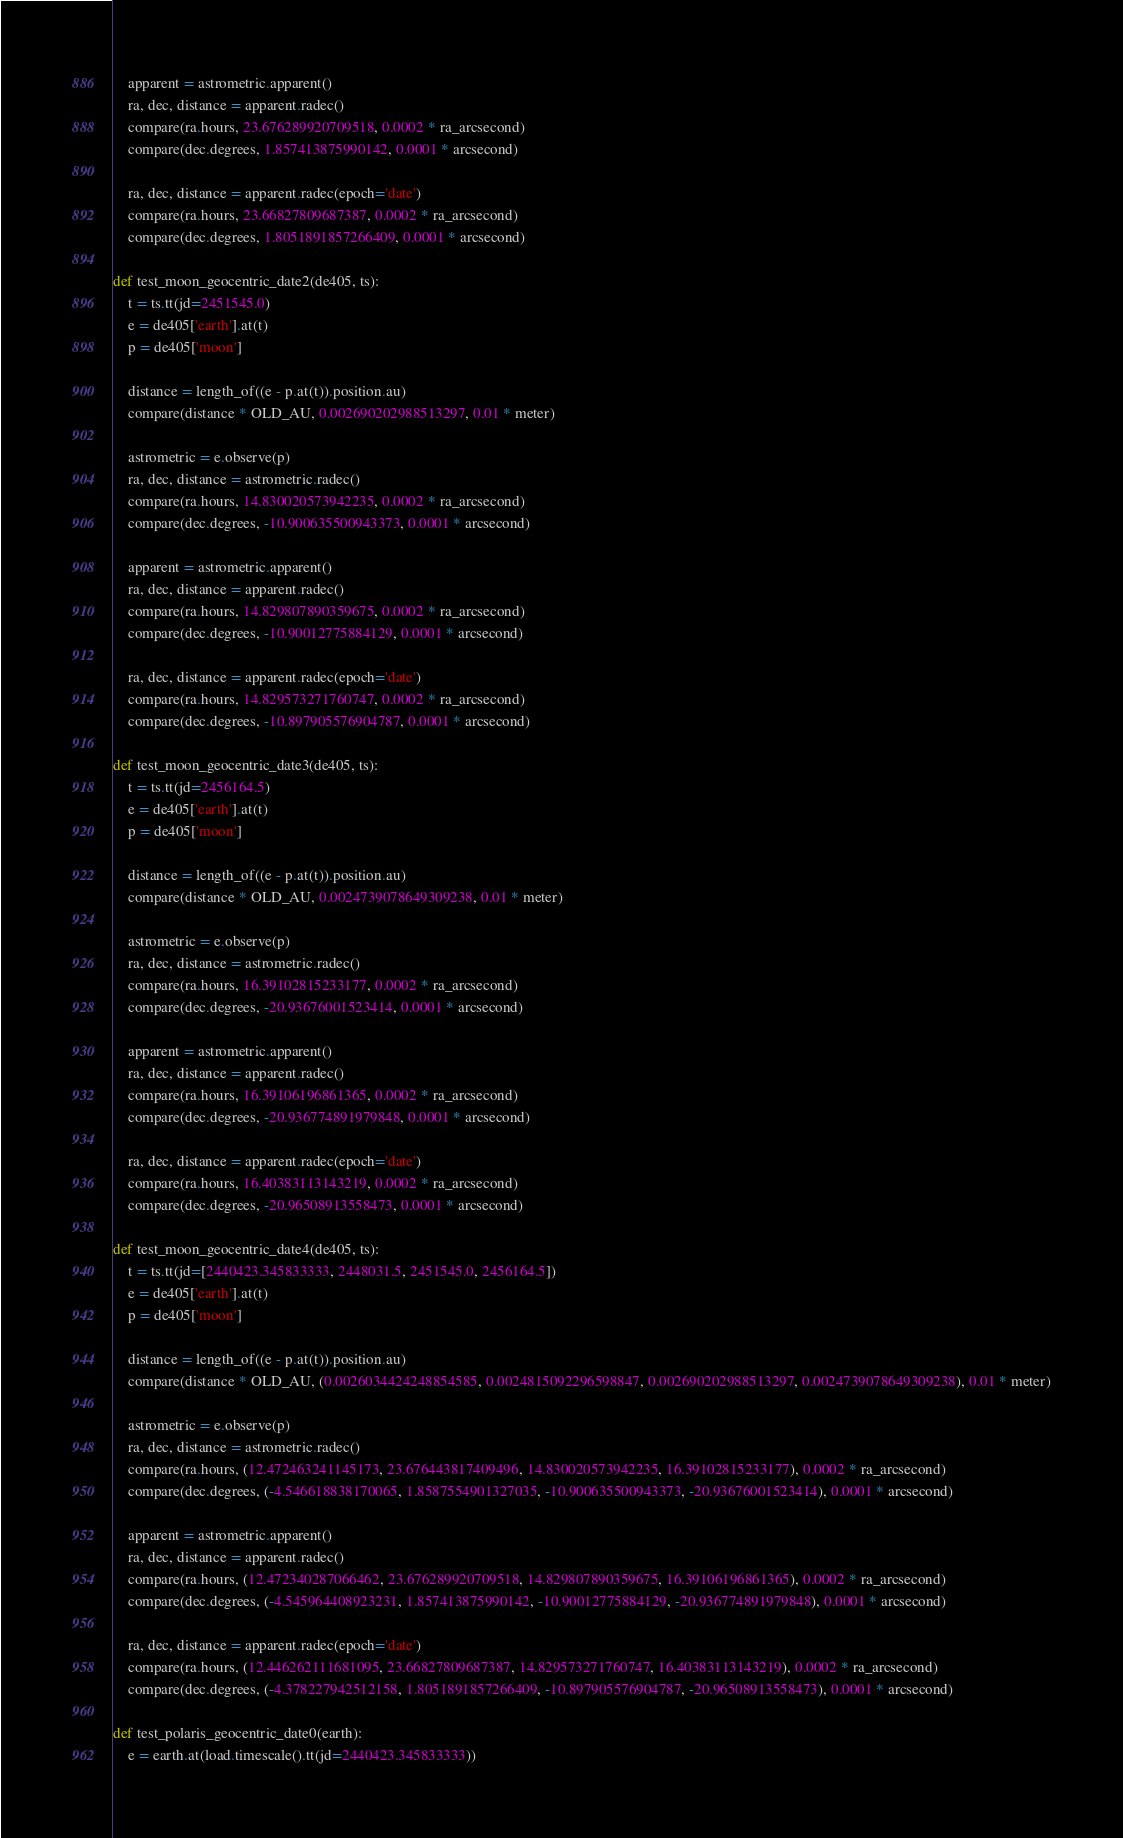<code> <loc_0><loc_0><loc_500><loc_500><_Python_>
    apparent = astrometric.apparent()
    ra, dec, distance = apparent.radec()
    compare(ra.hours, 23.676289920709518, 0.0002 * ra_arcsecond)
    compare(dec.degrees, 1.857413875990142, 0.0001 * arcsecond)

    ra, dec, distance = apparent.radec(epoch='date')
    compare(ra.hours, 23.66827809687387, 0.0002 * ra_arcsecond)
    compare(dec.degrees, 1.8051891857266409, 0.0001 * arcsecond)

def test_moon_geocentric_date2(de405, ts):
    t = ts.tt(jd=2451545.0)
    e = de405['earth'].at(t)
    p = de405['moon']

    distance = length_of((e - p.at(t)).position.au)
    compare(distance * OLD_AU, 0.002690202988513297, 0.01 * meter)

    astrometric = e.observe(p)
    ra, dec, distance = astrometric.radec()
    compare(ra.hours, 14.830020573942235, 0.0002 * ra_arcsecond)
    compare(dec.degrees, -10.900635500943373, 0.0001 * arcsecond)

    apparent = astrometric.apparent()
    ra, dec, distance = apparent.radec()
    compare(ra.hours, 14.829807890359675, 0.0002 * ra_arcsecond)
    compare(dec.degrees, -10.90012775884129, 0.0001 * arcsecond)

    ra, dec, distance = apparent.radec(epoch='date')
    compare(ra.hours, 14.829573271760747, 0.0002 * ra_arcsecond)
    compare(dec.degrees, -10.897905576904787, 0.0001 * arcsecond)

def test_moon_geocentric_date3(de405, ts):
    t = ts.tt(jd=2456164.5)
    e = de405['earth'].at(t)
    p = de405['moon']

    distance = length_of((e - p.at(t)).position.au)
    compare(distance * OLD_AU, 0.0024739078649309238, 0.01 * meter)

    astrometric = e.observe(p)
    ra, dec, distance = astrometric.radec()
    compare(ra.hours, 16.39102815233177, 0.0002 * ra_arcsecond)
    compare(dec.degrees, -20.93676001523414, 0.0001 * arcsecond)

    apparent = astrometric.apparent()
    ra, dec, distance = apparent.radec()
    compare(ra.hours, 16.39106196861365, 0.0002 * ra_arcsecond)
    compare(dec.degrees, -20.936774891979848, 0.0001 * arcsecond)

    ra, dec, distance = apparent.radec(epoch='date')
    compare(ra.hours, 16.40383113143219, 0.0002 * ra_arcsecond)
    compare(dec.degrees, -20.96508913558473, 0.0001 * arcsecond)

def test_moon_geocentric_date4(de405, ts):
    t = ts.tt(jd=[2440423.345833333, 2448031.5, 2451545.0, 2456164.5])
    e = de405['earth'].at(t)
    p = de405['moon']

    distance = length_of((e - p.at(t)).position.au)
    compare(distance * OLD_AU, (0.0026034424248854585, 0.0024815092296598847, 0.002690202988513297, 0.0024739078649309238), 0.01 * meter)

    astrometric = e.observe(p)
    ra, dec, distance = astrometric.radec()
    compare(ra.hours, (12.472463241145173, 23.676443817409496, 14.830020573942235, 16.39102815233177), 0.0002 * ra_arcsecond)
    compare(dec.degrees, (-4.546618838170065, 1.8587554901327035, -10.900635500943373, -20.93676001523414), 0.0001 * arcsecond)

    apparent = astrometric.apparent()
    ra, dec, distance = apparent.radec()
    compare(ra.hours, (12.472340287066462, 23.676289920709518, 14.829807890359675, 16.39106196861365), 0.0002 * ra_arcsecond)
    compare(dec.degrees, (-4.545964408923231, 1.857413875990142, -10.90012775884129, -20.936774891979848), 0.0001 * arcsecond)

    ra, dec, distance = apparent.radec(epoch='date')
    compare(ra.hours, (12.446262111681095, 23.66827809687387, 14.829573271760747, 16.40383113143219), 0.0002 * ra_arcsecond)
    compare(dec.degrees, (-4.378227942512158, 1.8051891857266409, -10.897905576904787, -20.96508913558473), 0.0001 * arcsecond)

def test_polaris_geocentric_date0(earth):
    e = earth.at(load.timescale().tt(jd=2440423.345833333))</code> 